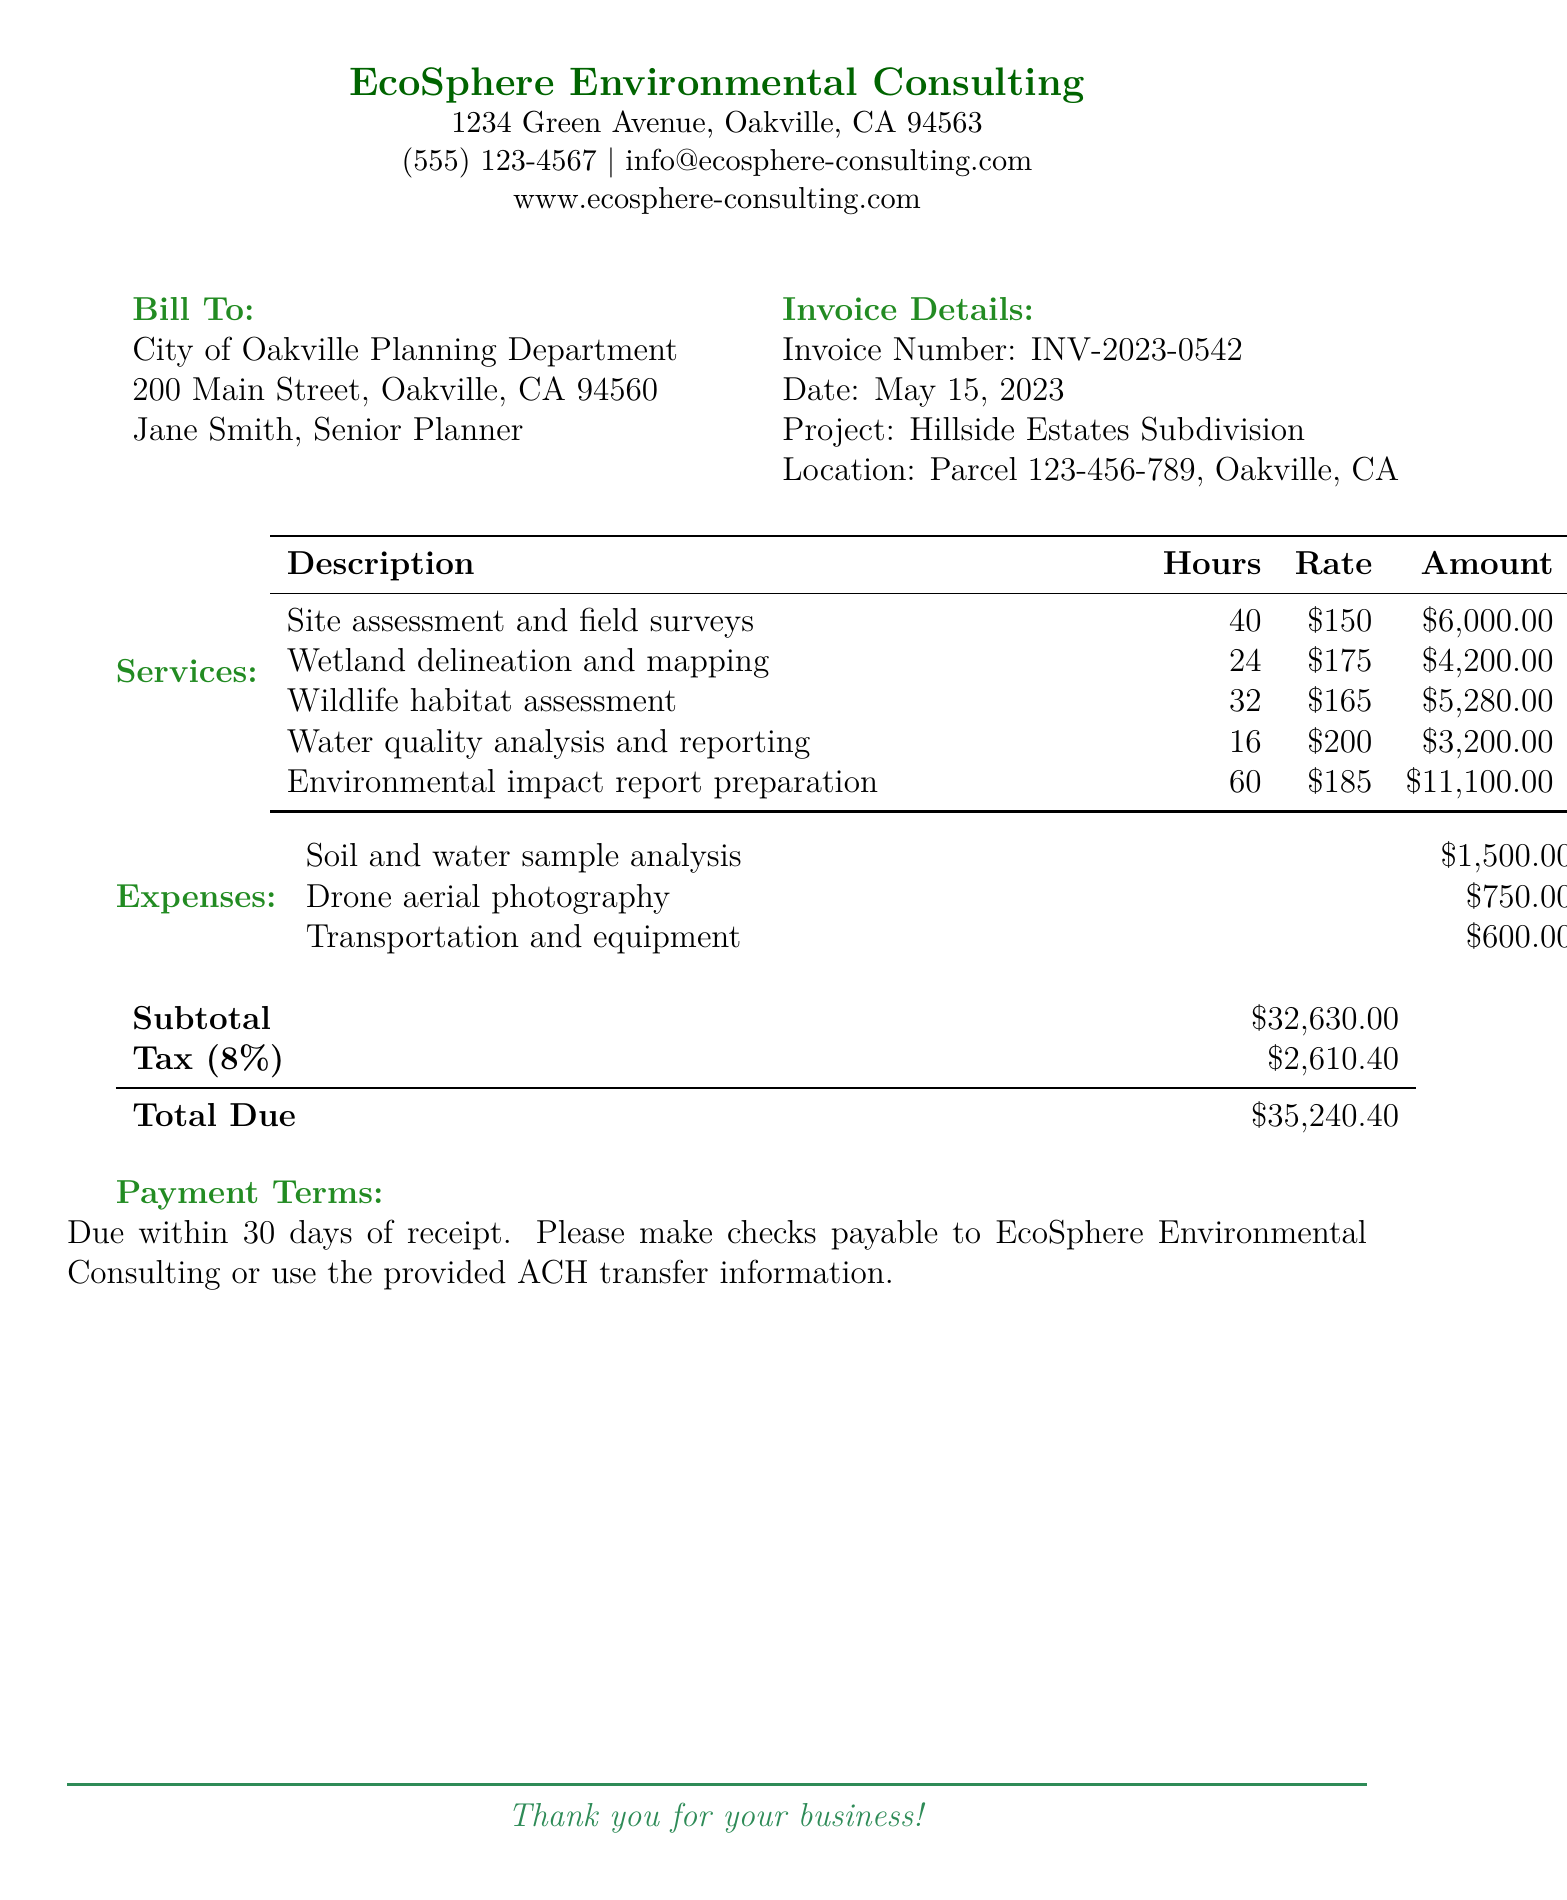What is the invoice number? The invoice number is listed under the invoice details section of the document.
Answer: INV-2023-0542 Who is the contact person for the City of Oakville? The contact person for the City of Oakville is named in the bill-to section of the document.
Answer: Jane Smith, Senior Planner What is the total amount due? The total amount due is shown at the end of the bill under the total due section.
Answer: $35,240.40 How many hours were spent on wetland delineation and mapping? The number of hours for this service is detailed in the services table of the document.
Answer: 24 What is the rate for environmental impact report preparation? The rate for this specific service can be found in the services table.
Answer: $185 What is the tax percentage applied to the subtotal? The percentage of tax applied is indicated below the subtotal in the document.
Answer: 8% What is the due date for payment? The payment terms specify the due date within the document.
Answer: 30 days of receipt What is the total amount for soil and water sample analysis? The cost for this item is included in the expenses section of the document.
Answer: $1,500.00 What service had the highest charge? By reviewing the services table, the highest charge can be determined.
Answer: Environmental impact report preparation 